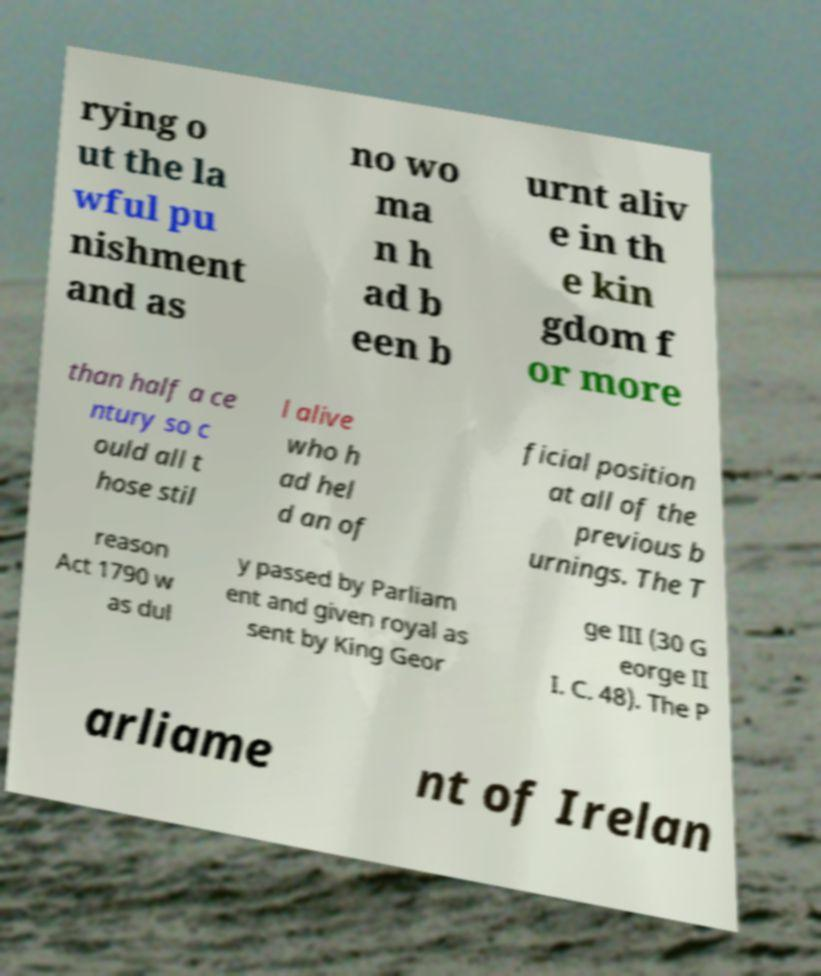Could you assist in decoding the text presented in this image and type it out clearly? rying o ut the la wful pu nishment and as no wo ma n h ad b een b urnt aliv e in th e kin gdom f or more than half a ce ntury so c ould all t hose stil l alive who h ad hel d an of ficial position at all of the previous b urnings. The T reason Act 1790 w as dul y passed by Parliam ent and given royal as sent by King Geor ge III (30 G eorge II I. C. 48). The P arliame nt of Irelan 